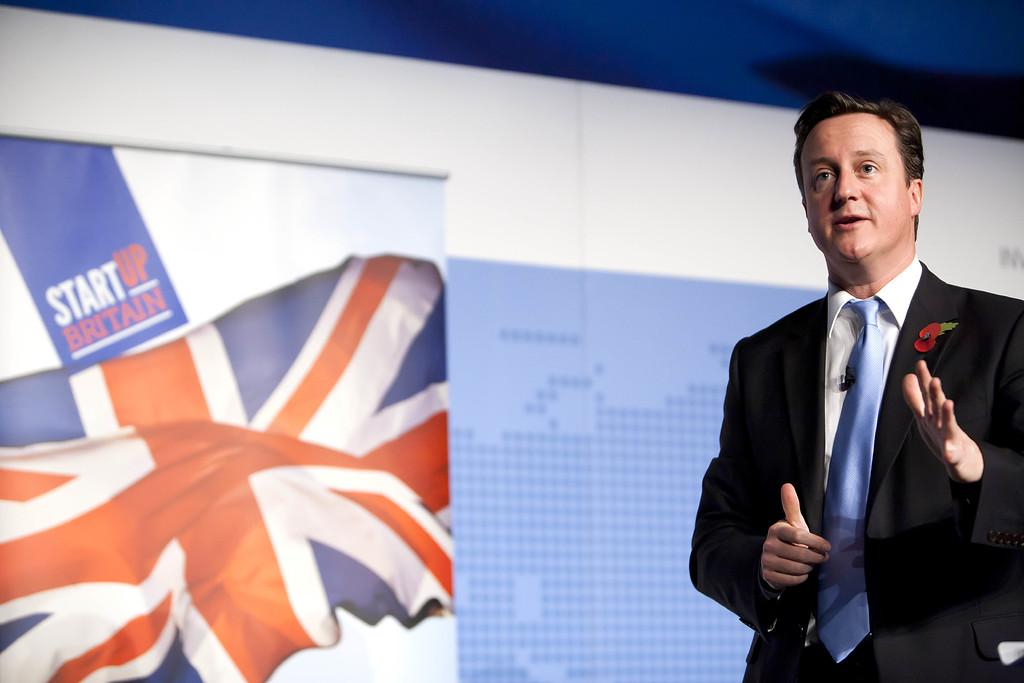Who is present in the image? There is a man in the image. What is the man doing in the image? The man is standing in the image. What is the man wearing in the image? The man is wearing a suit in the image. What can be seen in the background of the image? There is a projector screen in the background of the image. What additional object is present in the image? There is a flag in the image. What is the man learning in the image? There is no indication in the image that the man is learning anything. 